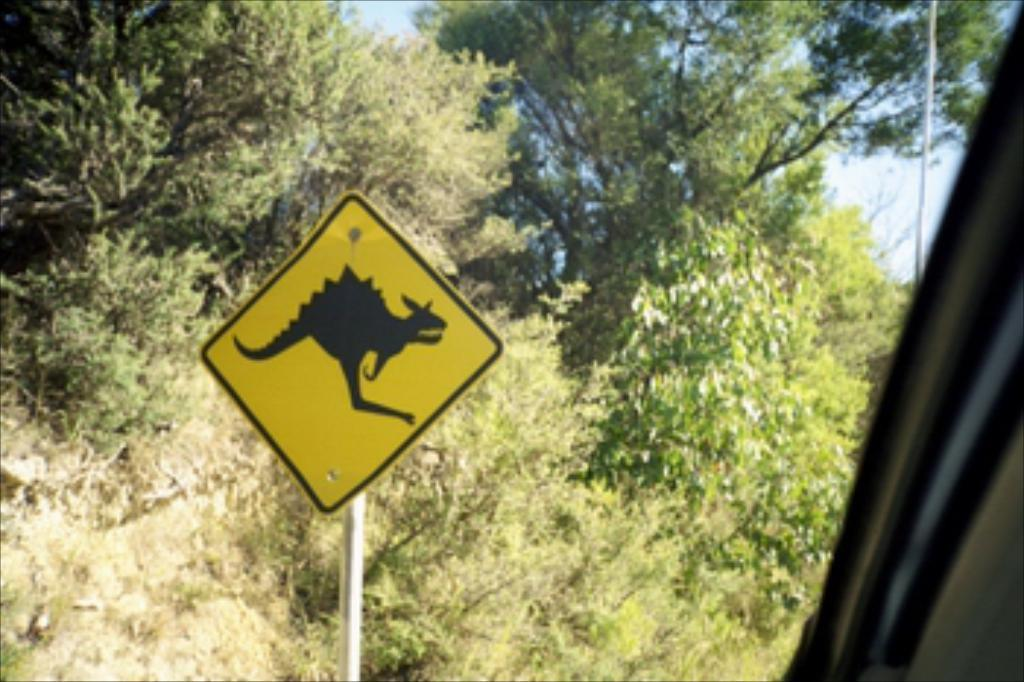What is the main object in the image? There is a yellow and black color board in the image. How is the color board positioned in the image? The board is attached to a pole. What else can be seen in the image besides the color board? There is a vehicle visible in the image. What can be seen in the background of the image? There are many trees and the sky visible in the background of the image. What time of day is it in the image, and what type of rod is being used by the person in the crib? There is no information about the time of day or a person in a crib in the image. 